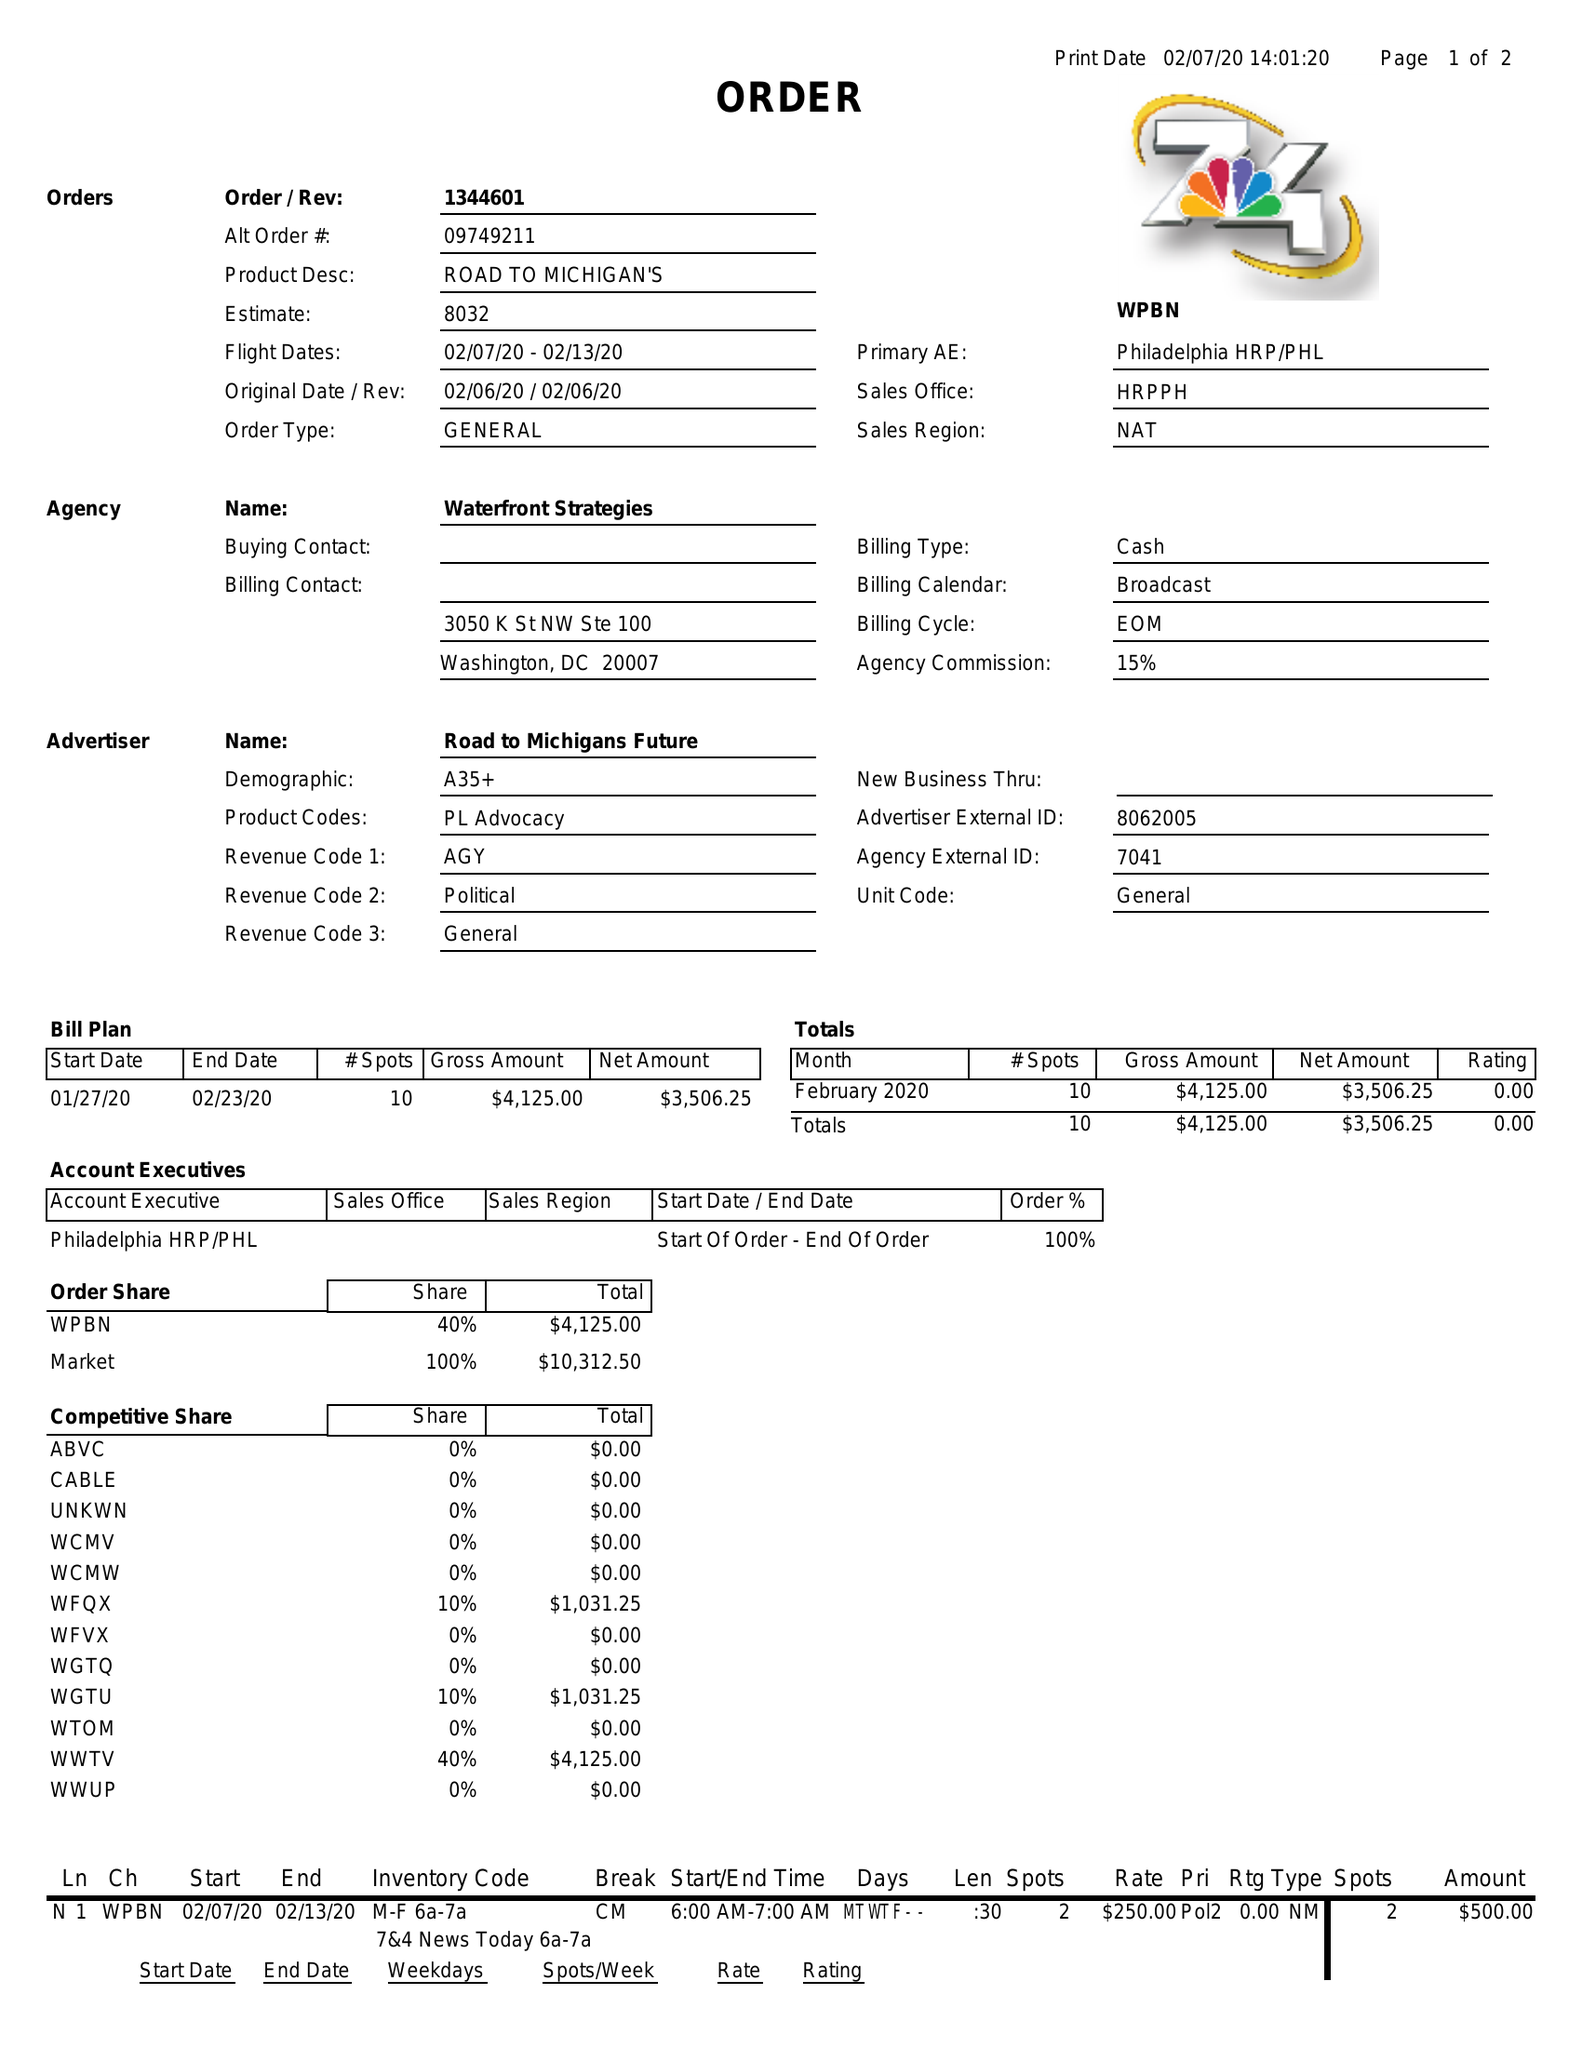What is the value for the contract_num?
Answer the question using a single word or phrase. 1344601 